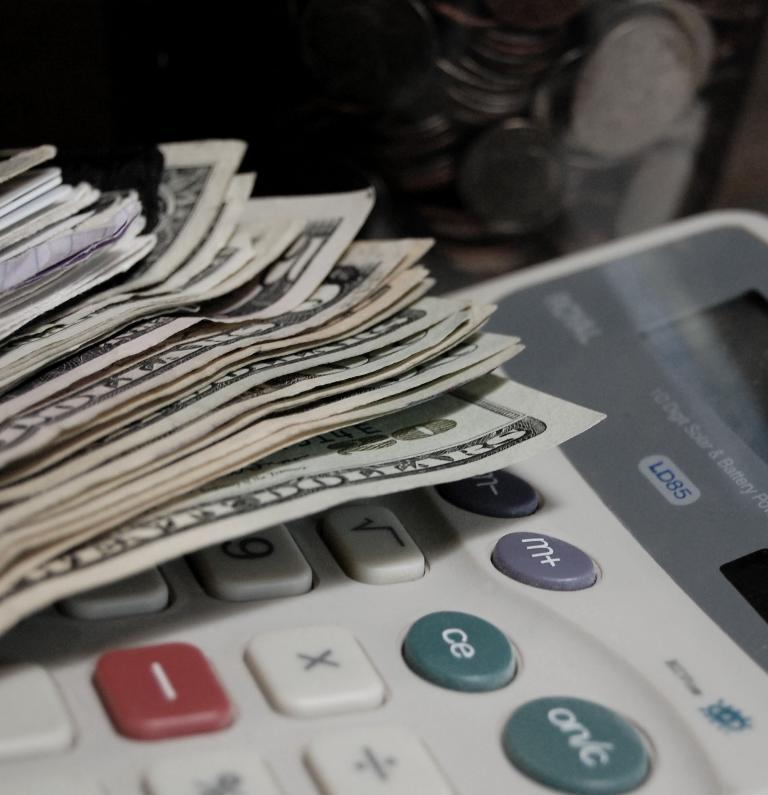Provide a one-sentence caption for the provided image. A stack of American twenty dollar and 5 dollar bills sits on top of an LD85 calculator. 